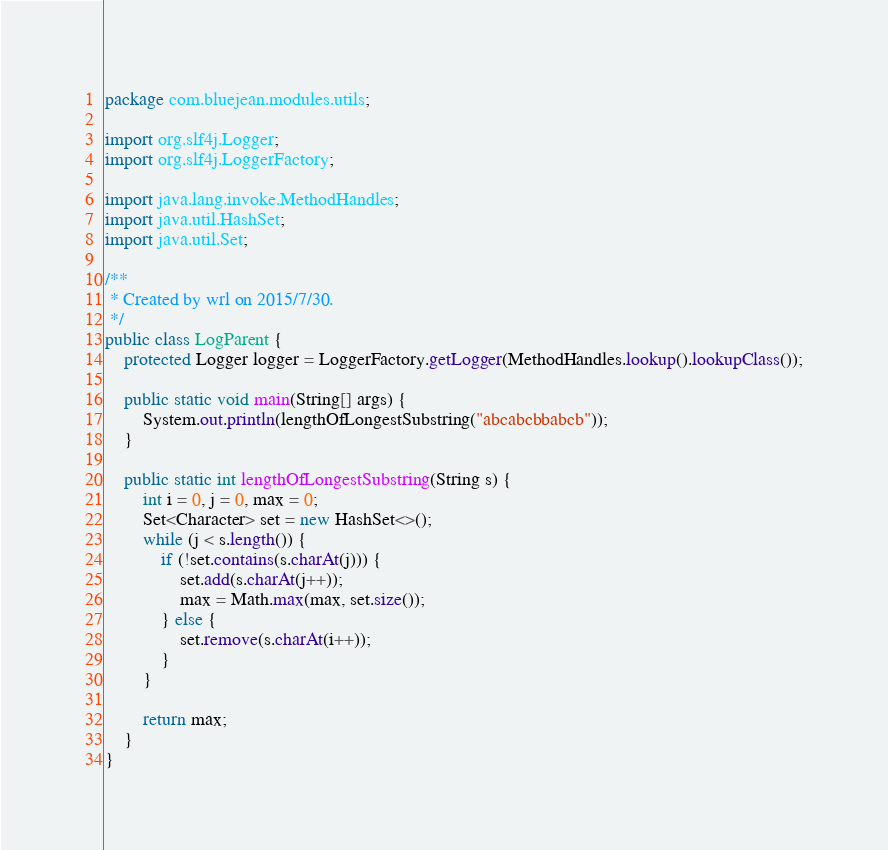Convert code to text. <code><loc_0><loc_0><loc_500><loc_500><_Java_>package com.bluejean.modules.utils;

import org.slf4j.Logger;
import org.slf4j.LoggerFactory;

import java.lang.invoke.MethodHandles;
import java.util.HashSet;
import java.util.Set;

/**
 * Created by wrl on 2015/7/30.
 */
public class LogParent {
    protected Logger logger = LoggerFactory.getLogger(MethodHandles.lookup().lookupClass());

    public static void main(String[] args) {
        System.out.println(lengthOfLongestSubstring("abcabcbbabcb"));
    }

    public static int lengthOfLongestSubstring(String s) {
        int i = 0, j = 0, max = 0;
        Set<Character> set = new HashSet<>();
        while (j < s.length()) {
            if (!set.contains(s.charAt(j))) {
                set.add(s.charAt(j++));
                max = Math.max(max, set.size());
            } else {
                set.remove(s.charAt(i++));
            }
        }

        return max;
    }
}
</code> 